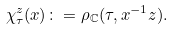Convert formula to latex. <formula><loc_0><loc_0><loc_500><loc_500>\chi _ { \tau } ^ { z } ( x ) \colon = \rho _ { \mathbb { C } } ( \tau , x ^ { - 1 } z ) .</formula> 